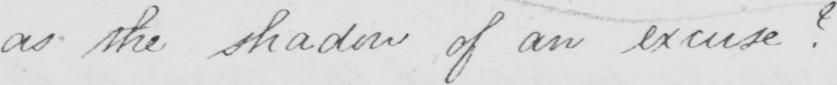Please provide the text content of this handwritten line. as the shadow of an excuse ? 